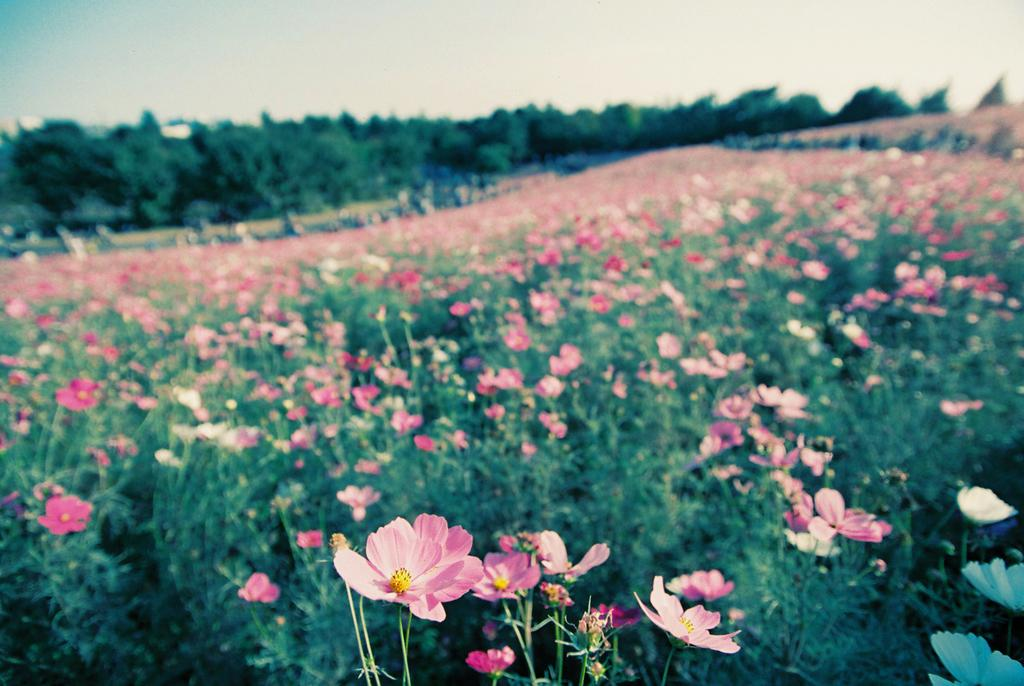What type of landscape is depicted in the image? There is a beautiful flowers garden in the image. Are there any specific features within the garden? Yes, there are trees in the middle of the garden. What can be seen above the garden in the image? The sky is visible at the top of the image. What type of dress is the person wearing in the image? There is no person present in the image, so it is not possible to determine what type of dress they might be wearing. 